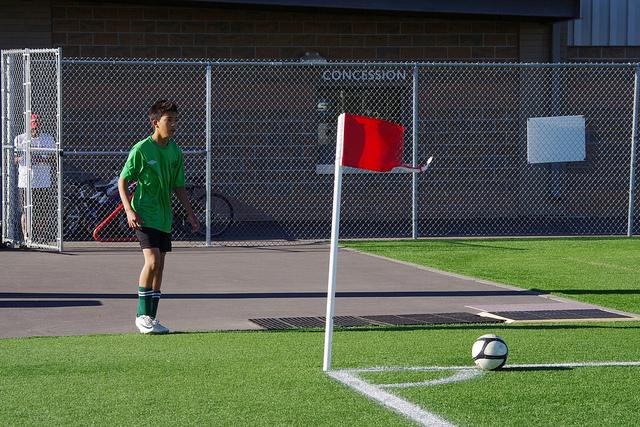Where could a person get snacks?
Concise answer only. Concession. How many pictures are shown?
Give a very brief answer. 1. What is the boy looking at?
Give a very brief answer. Soccer field. What sport is he playing?
Give a very brief answer. Soccer. What color is the flag?
Short answer required. Red. 